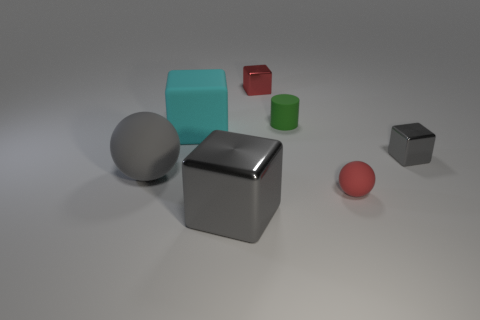Subtract all red blocks. How many blocks are left? 3 Add 2 big metallic objects. How many objects exist? 9 Subtract 2 spheres. How many spheres are left? 0 Subtract all gray balls. How many balls are left? 1 Subtract all balls. How many objects are left? 5 Subtract all large balls. Subtract all green things. How many objects are left? 5 Add 5 small gray cubes. How many small gray cubes are left? 6 Add 7 large shiny objects. How many large shiny objects exist? 8 Subtract 0 purple blocks. How many objects are left? 7 Subtract all gray balls. Subtract all brown cylinders. How many balls are left? 1 